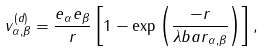<formula> <loc_0><loc_0><loc_500><loc_500>v _ { \alpha , \beta } ^ { ( d ) } = \frac { e _ { \alpha } e _ { \beta } } { r } \left [ 1 - \exp \left ( \frac { - r } { { \lambda b a r } _ { \alpha , \beta } } \right ) \right ] ,</formula> 